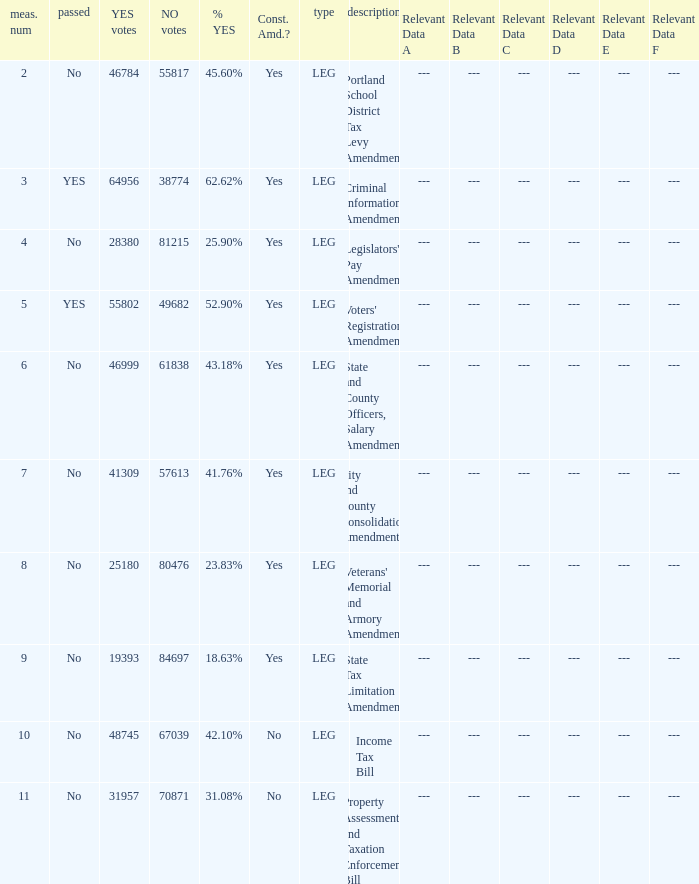How many yes votes made up 43.18% yes? 46999.0. 